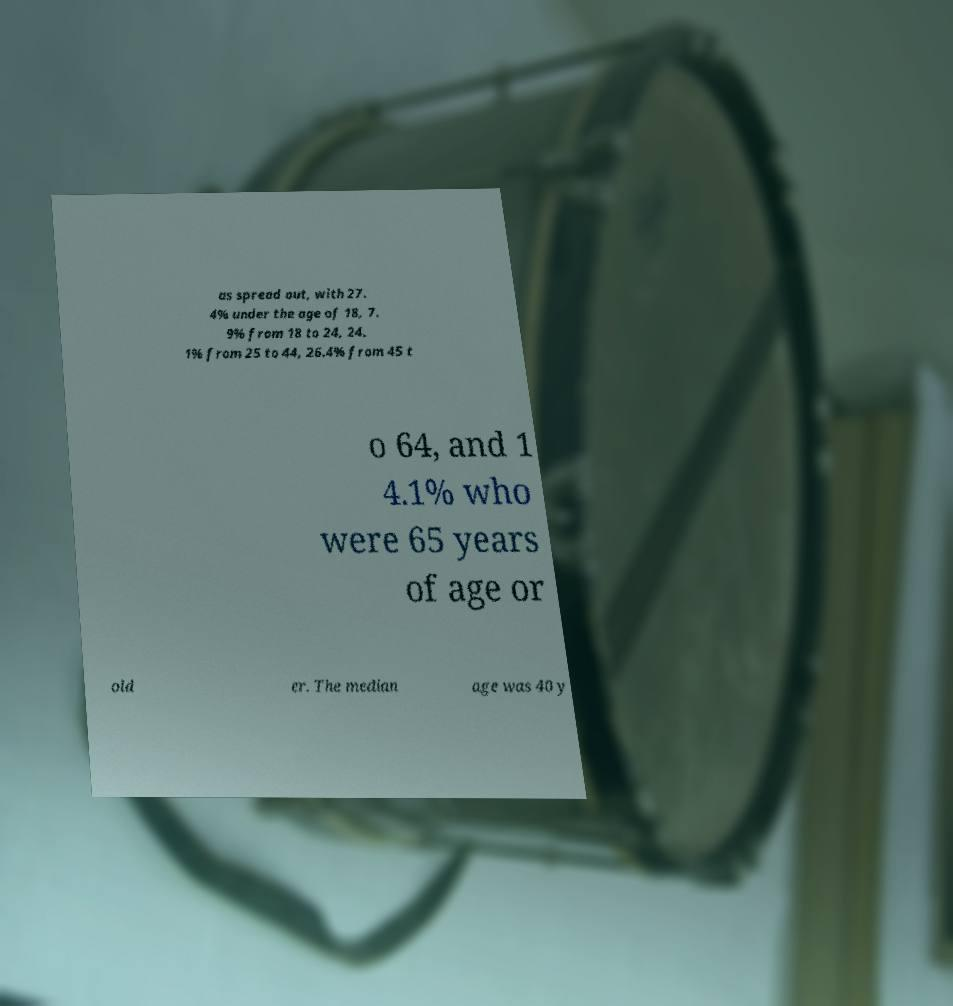What messages or text are displayed in this image? I need them in a readable, typed format. as spread out, with 27. 4% under the age of 18, 7. 9% from 18 to 24, 24. 1% from 25 to 44, 26.4% from 45 t o 64, and 1 4.1% who were 65 years of age or old er. The median age was 40 y 